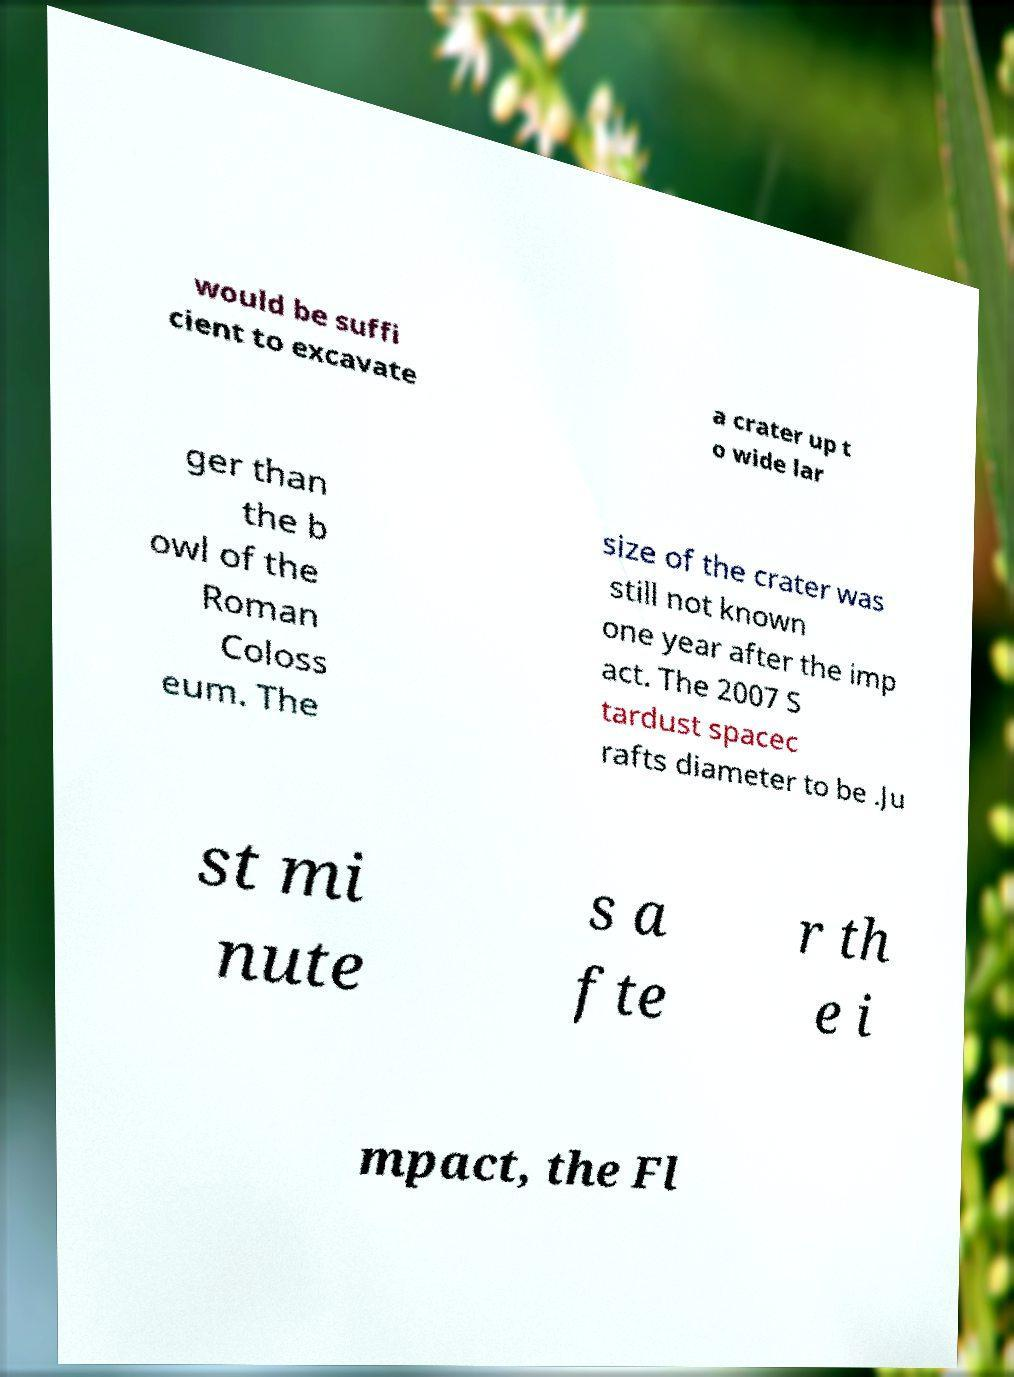For documentation purposes, I need the text within this image transcribed. Could you provide that? would be suffi cient to excavate a crater up t o wide lar ger than the b owl of the Roman Coloss eum. The size of the crater was still not known one year after the imp act. The 2007 S tardust spacec rafts diameter to be .Ju st mi nute s a fte r th e i mpact, the Fl 